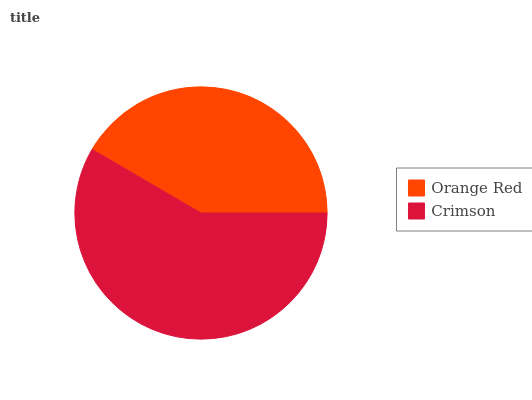Is Orange Red the minimum?
Answer yes or no. Yes. Is Crimson the maximum?
Answer yes or no. Yes. Is Crimson the minimum?
Answer yes or no. No. Is Crimson greater than Orange Red?
Answer yes or no. Yes. Is Orange Red less than Crimson?
Answer yes or no. Yes. Is Orange Red greater than Crimson?
Answer yes or no. No. Is Crimson less than Orange Red?
Answer yes or no. No. Is Crimson the high median?
Answer yes or no. Yes. Is Orange Red the low median?
Answer yes or no. Yes. Is Orange Red the high median?
Answer yes or no. No. Is Crimson the low median?
Answer yes or no. No. 